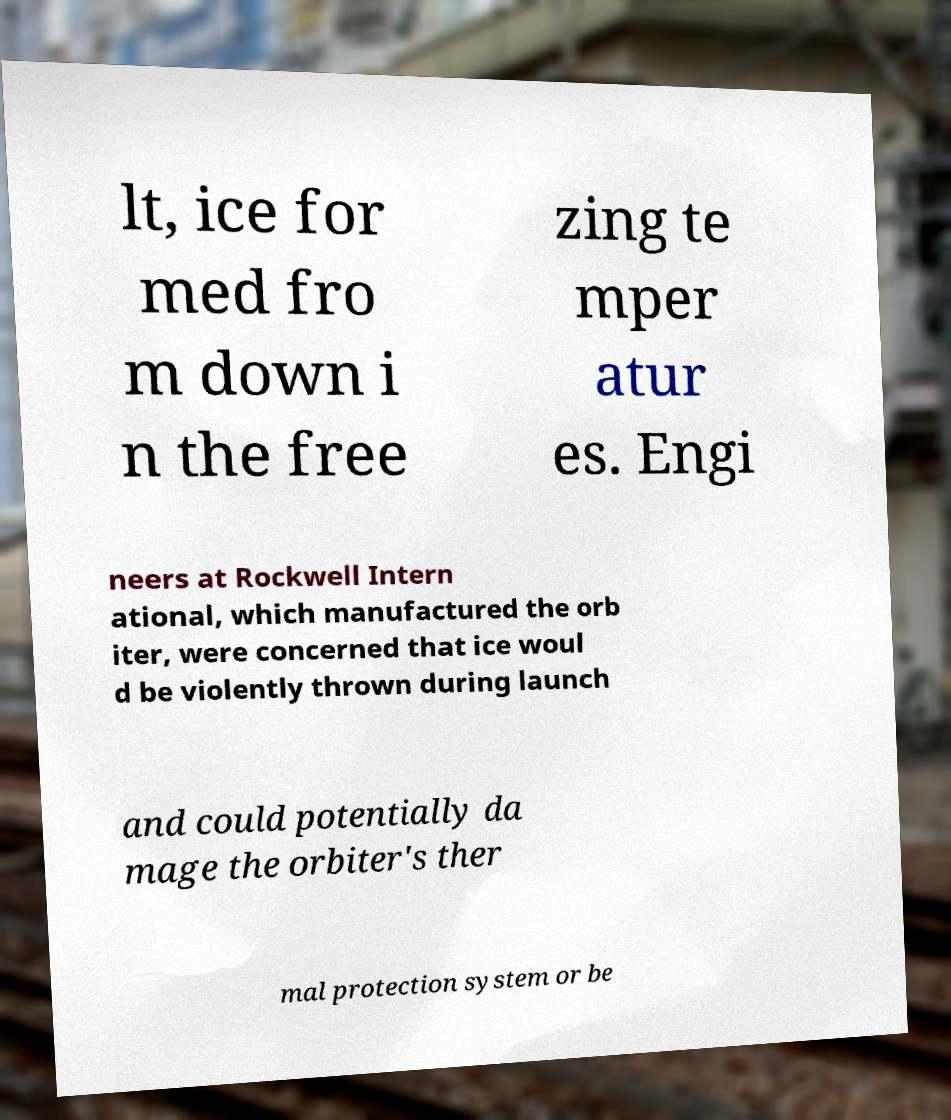Could you assist in decoding the text presented in this image and type it out clearly? lt, ice for med fro m down i n the free zing te mper atur es. Engi neers at Rockwell Intern ational, which manufactured the orb iter, were concerned that ice woul d be violently thrown during launch and could potentially da mage the orbiter's ther mal protection system or be 